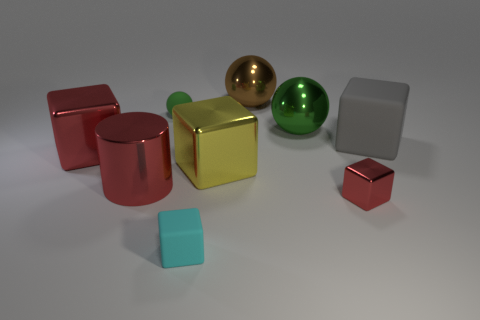Is the color of the large cylinder the same as the tiny metallic block?
Provide a short and direct response. Yes. There is a matte object that is behind the tiny cyan matte block and left of the big yellow metallic cube; what color is it?
Your response must be concise. Green. Are the big cylinder and the tiny object that is behind the metallic cylinder made of the same material?
Provide a short and direct response. No. Is the number of matte blocks that are in front of the big rubber object less than the number of small gray cubes?
Make the answer very short. No. How many other things are there of the same shape as the big yellow metallic object?
Ensure brevity in your answer.  4. Is there any other thing of the same color as the tiny matte cube?
Offer a very short reply. No. Do the shiny cylinder and the metal object that is to the right of the big green ball have the same color?
Your response must be concise. Yes. What number of other things are there of the same size as the gray matte cube?
Give a very brief answer. 5. There is another ball that is the same color as the rubber ball; what size is it?
Provide a short and direct response. Large. What number of cylinders are big gray things or small rubber things?
Your response must be concise. 0. 